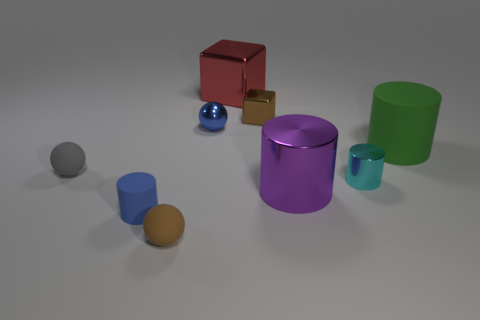What color is the small matte cylinder? The small matte cylinder in the image is blue, which stands out against the various shades present in the scene, providing a pleasing contrast with the other objects. 